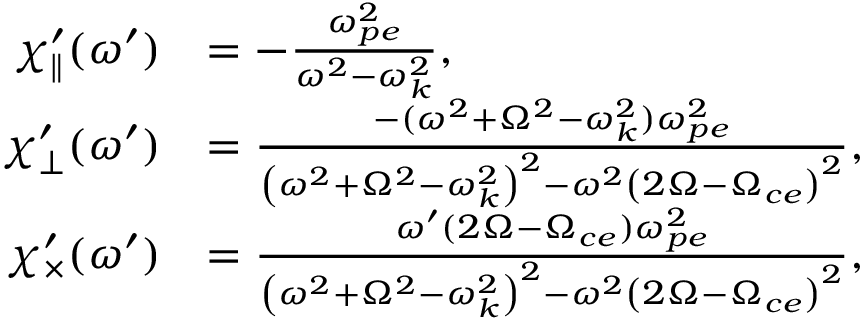Convert formula to latex. <formula><loc_0><loc_0><loc_500><loc_500>\begin{array} { r l } { \chi _ { \| } ^ { \prime } ( \omega ^ { \prime } ) } & { = - \frac { \omega _ { p e } ^ { 2 } } { \omega ^ { 2 } - \omega _ { k } ^ { 2 } } , } \\ { { \chi _ { \perp } ^ { \prime } } ( \omega ^ { \prime } ) } & { = \frac { - ( \omega ^ { 2 } + \Omega ^ { 2 } - \omega _ { k } ^ { 2 } ) \omega _ { p e } ^ { 2 } } { \left ( \omega ^ { 2 } + \Omega ^ { 2 } - \omega _ { k } ^ { 2 } \right ) ^ { 2 } - \omega ^ { 2 } \left ( 2 \Omega - \Omega _ { c e } \right ) ^ { 2 } } , } \\ { { \chi _ { \times } ^ { \prime } } ( \omega ^ { \prime } ) } & { = \frac { \omega ^ { \prime } ( 2 \Omega - \Omega _ { c e } ) \omega _ { p e } ^ { 2 } } { \left ( \omega ^ { 2 } + \Omega ^ { 2 } - \omega _ { k } ^ { 2 } \right ) ^ { 2 } - \omega ^ { 2 } \left ( 2 \Omega - \Omega _ { c e } \right ) ^ { 2 } } , } \end{array}</formula> 